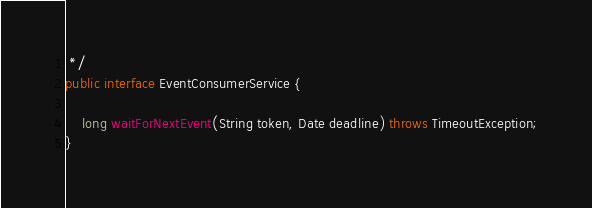Convert code to text. <code><loc_0><loc_0><loc_500><loc_500><_Java_> */
public interface EventConsumerService {

    long waitForNextEvent(String token, Date deadline) throws TimeoutException;
}
</code> 